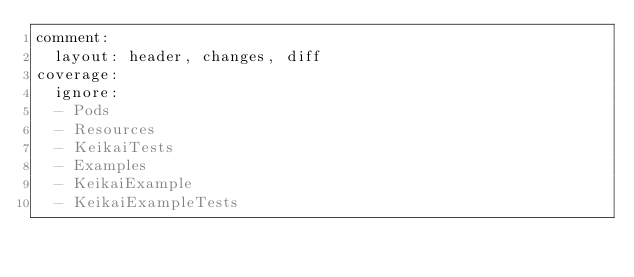<code> <loc_0><loc_0><loc_500><loc_500><_YAML_>comment:
  layout: header, changes, diff
coverage:
  ignore:
  - Pods
  - Resources
  - KeikaiTests
  - Examples
  - KeikaiExample
  - KeikaiExampleTests</code> 